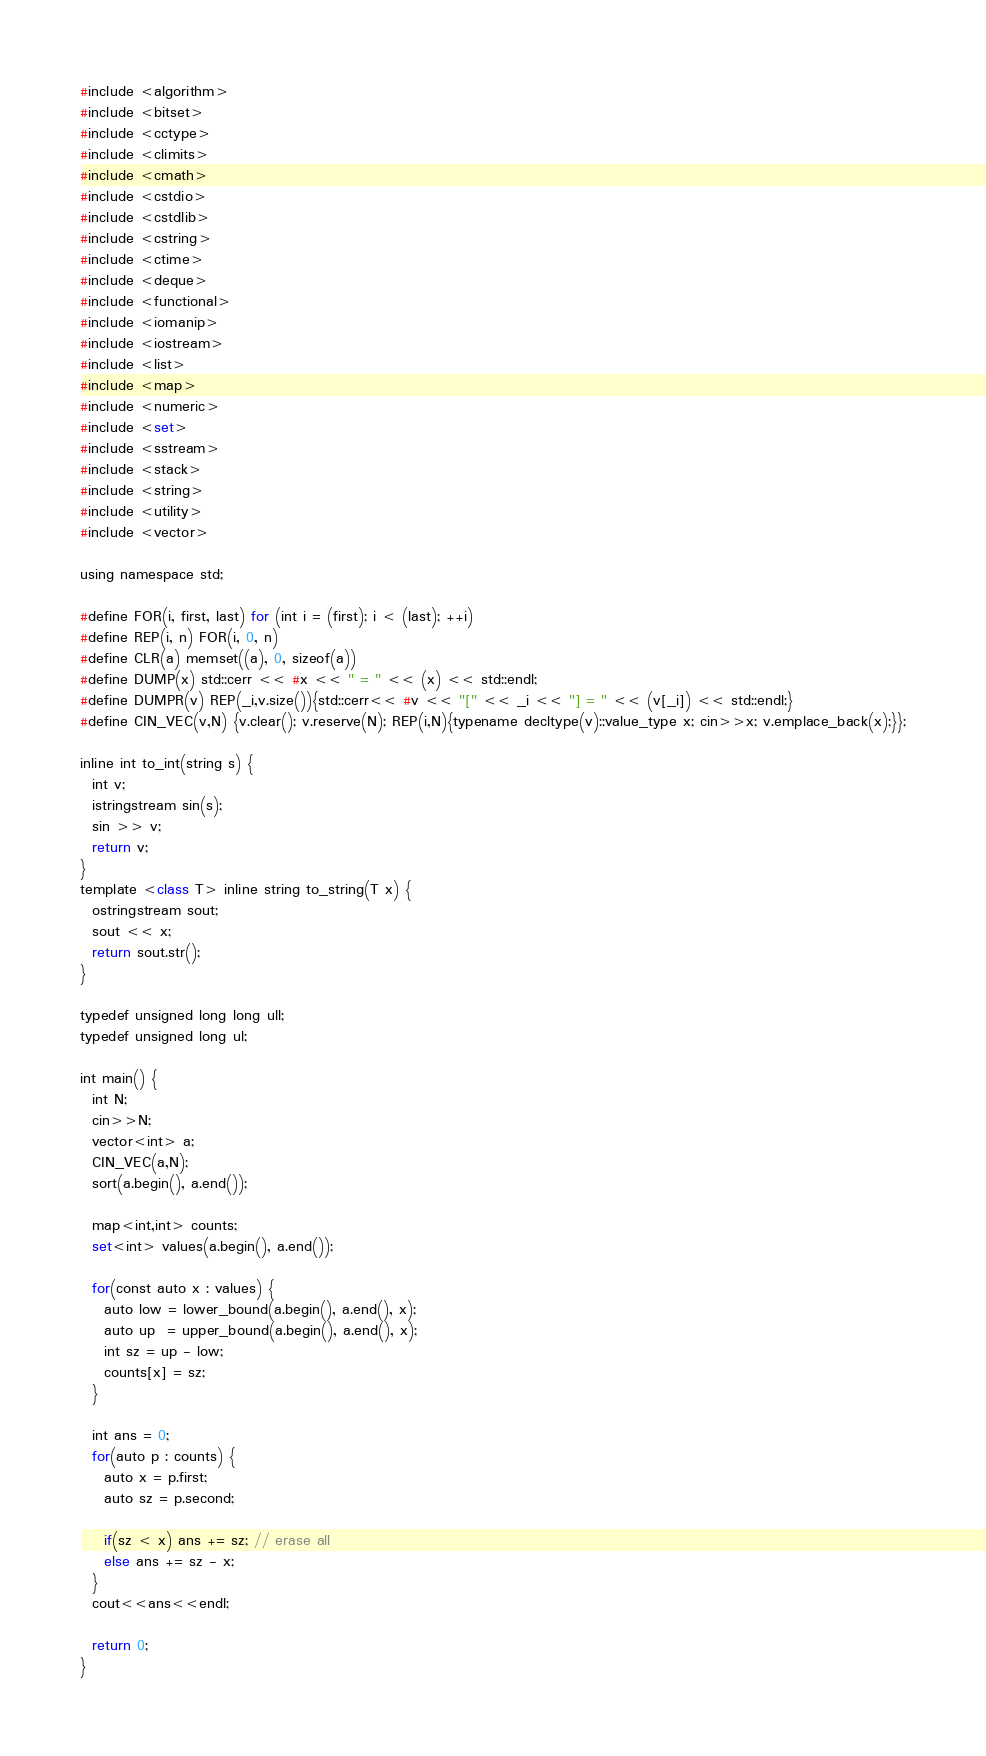Convert code to text. <code><loc_0><loc_0><loc_500><loc_500><_Kotlin_>#include <algorithm>
#include <bitset>
#include <cctype>
#include <climits>
#include <cmath>
#include <cstdio>
#include <cstdlib>
#include <cstring>
#include <ctime>
#include <deque>
#include <functional>
#include <iomanip>
#include <iostream>
#include <list>
#include <map>
#include <numeric>
#include <set>
#include <sstream>
#include <stack>
#include <string>
#include <utility>
#include <vector>

using namespace std;

#define FOR(i, first, last) for (int i = (first); i < (last); ++i)
#define REP(i, n) FOR(i, 0, n)
#define CLR(a) memset((a), 0, sizeof(a))
#define DUMP(x) std::cerr << #x << " = " << (x) << std::endl;
#define DUMPR(v) REP(_i,v.size()){std::cerr<< #v << "[" << _i << "] = " << (v[_i]) << std::endl;}
#define CIN_VEC(v,N) {v.clear(); v.reserve(N); REP(i,N){typename decltype(v)::value_type x; cin>>x; v.emplace_back(x);}};

inline int to_int(string s) {
  int v;
  istringstream sin(s);
  sin >> v;
  return v;
}
template <class T> inline string to_string(T x) {
  ostringstream sout;
  sout << x;
  return sout.str();
}

typedef unsigned long long ull;
typedef unsigned long ul;

int main() {
  int N;
  cin>>N;
  vector<int> a;
  CIN_VEC(a,N);
  sort(a.begin(), a.end());

  map<int,int> counts;
  set<int> values(a.begin(), a.end());

  for(const auto x : values) {
    auto low = lower_bound(a.begin(), a.end(), x);
    auto up  = upper_bound(a.begin(), a.end(), x);
    int sz = up - low;
    counts[x] = sz;
  }

  int ans = 0;
  for(auto p : counts) {
    auto x = p.first;
    auto sz = p.second;

    if(sz < x) ans += sz; // erase all
    else ans += sz - x;
  }
  cout<<ans<<endl;

  return 0;
}
</code> 